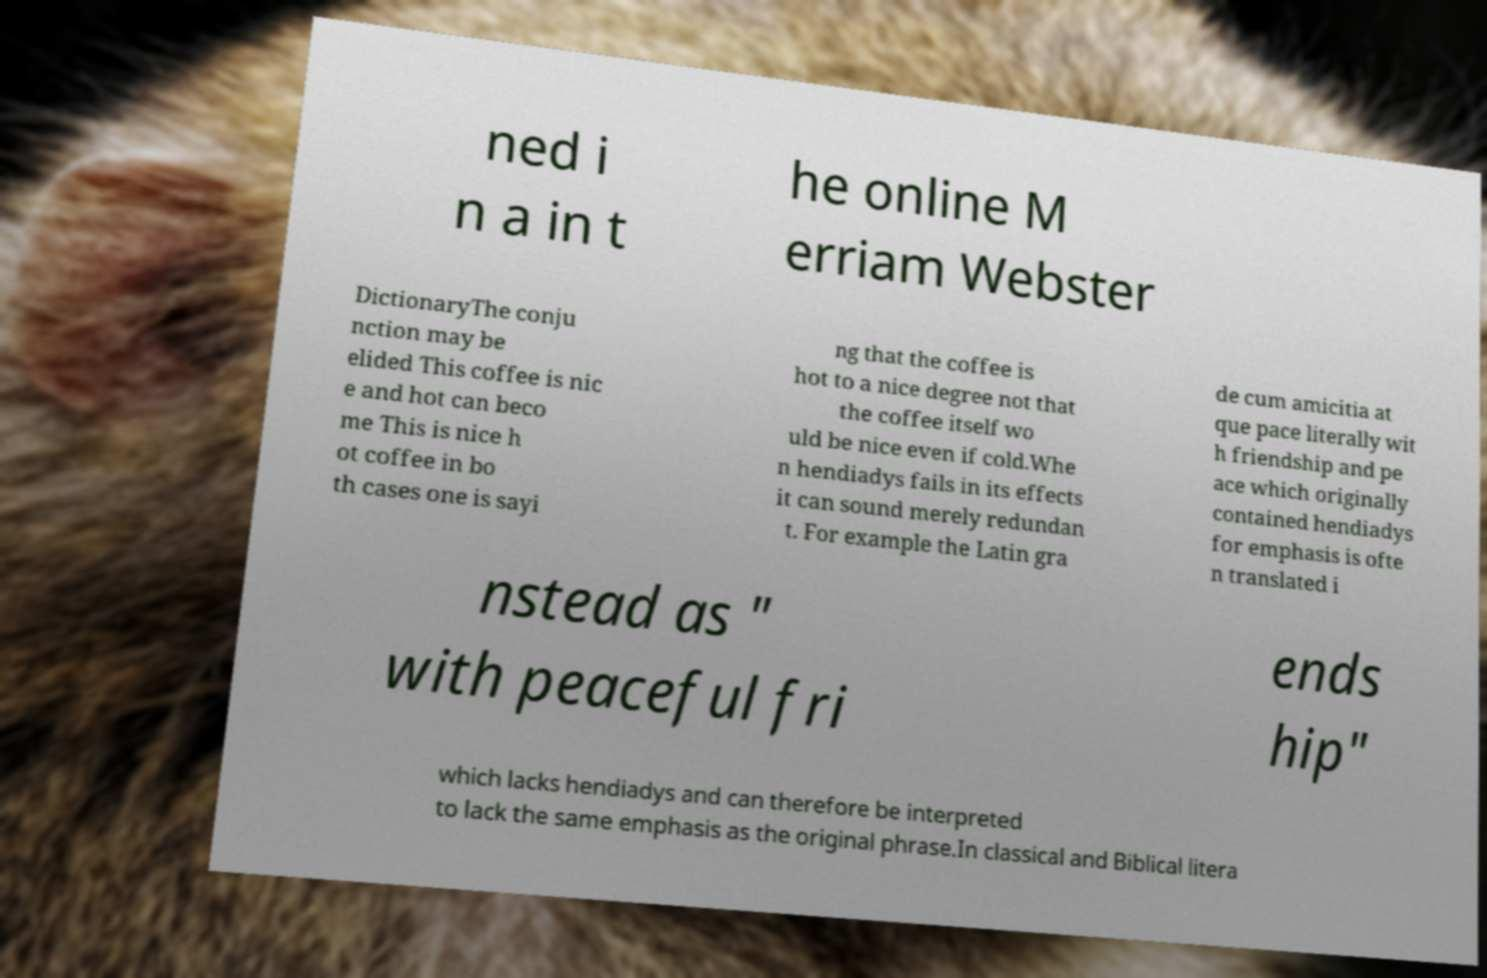What messages or text are displayed in this image? I need them in a readable, typed format. ned i n a in t he online M erriam Webster DictionaryThe conju nction may be elided This coffee is nic e and hot can beco me This is nice h ot coffee in bo th cases one is sayi ng that the coffee is hot to a nice degree not that the coffee itself wo uld be nice even if cold.Whe n hendiadys fails in its effects it can sound merely redundan t. For example the Latin gra de cum amicitia at que pace literally wit h friendship and pe ace which originally contained hendiadys for emphasis is ofte n translated i nstead as " with peaceful fri ends hip" which lacks hendiadys and can therefore be interpreted to lack the same emphasis as the original phrase.In classical and Biblical litera 